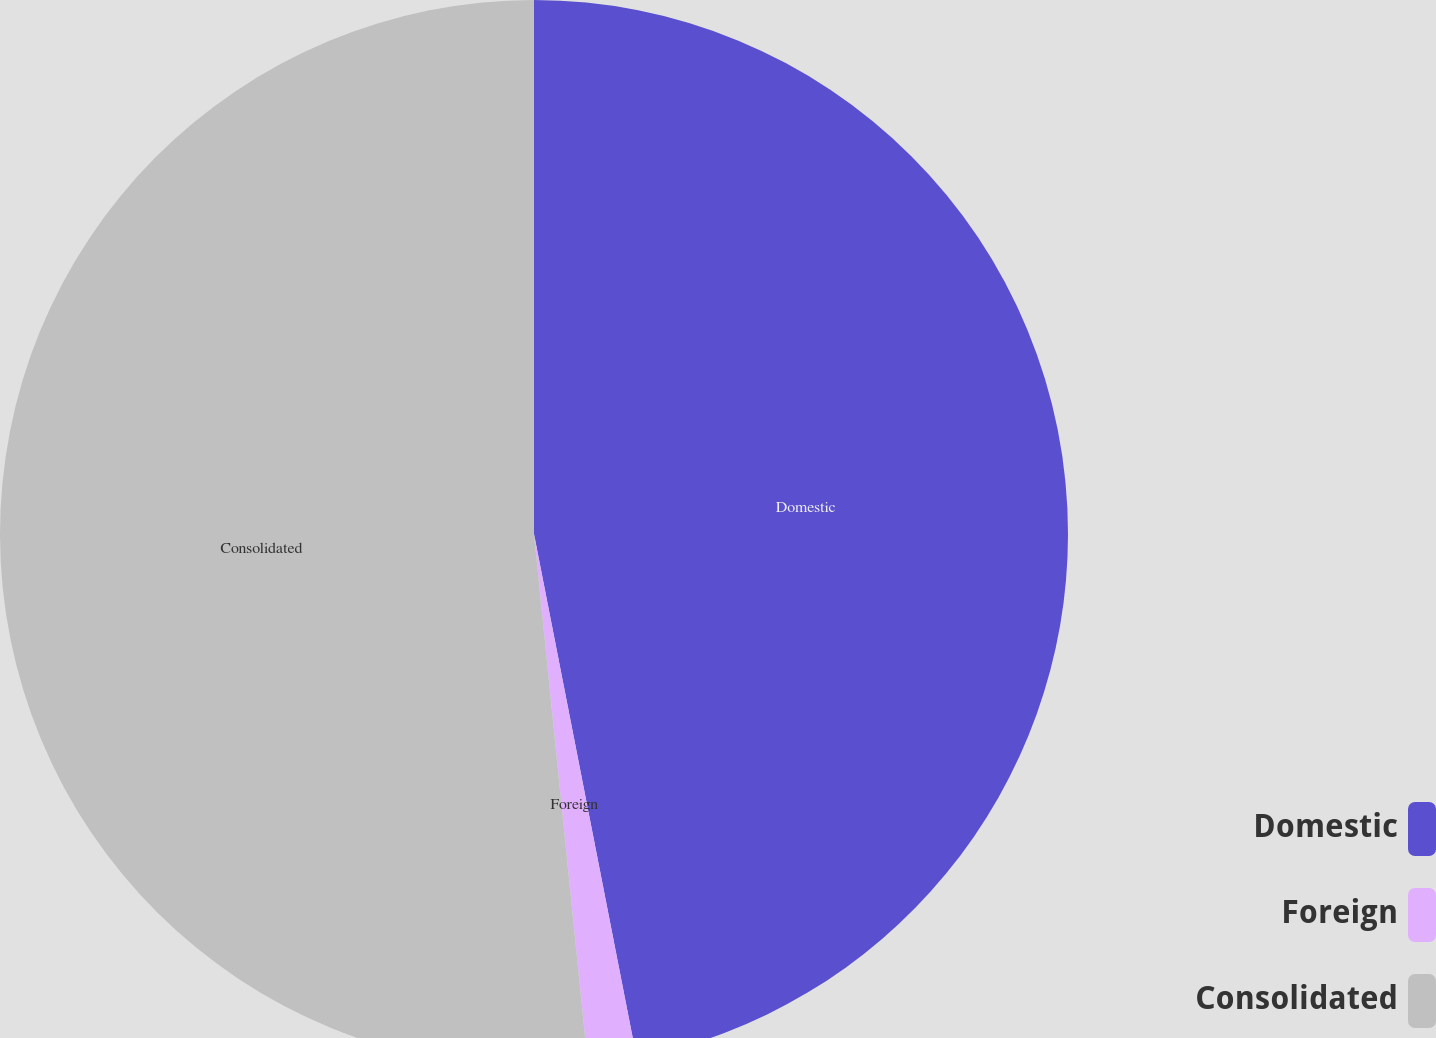Convert chart to OTSL. <chart><loc_0><loc_0><loc_500><loc_500><pie_chart><fcel>Domestic<fcel>Foreign<fcel>Consolidated<nl><fcel>46.92%<fcel>1.47%<fcel>51.61%<nl></chart> 